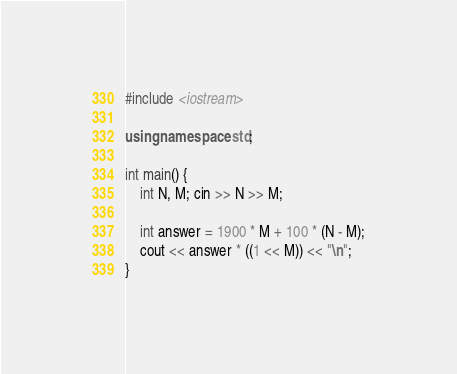<code> <loc_0><loc_0><loc_500><loc_500><_C++_>#include <iostream>

using namespace std;

int main() {
    int N, M; cin >> N >> M;

    int answer = 1900 * M + 100 * (N - M);
    cout << answer * ((1 << M)) << "\n";
}
</code> 